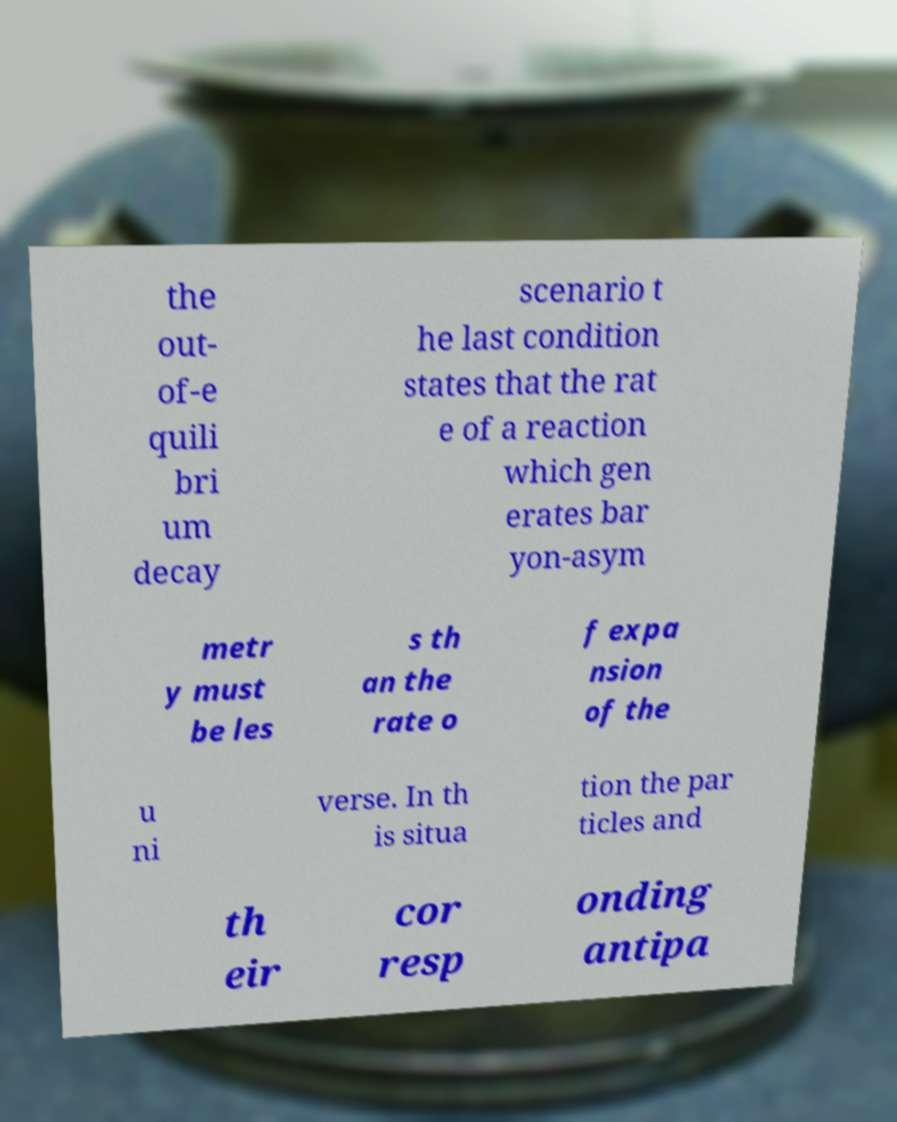What messages or text are displayed in this image? I need them in a readable, typed format. the out- of-e quili bri um decay scenario t he last condition states that the rat e of a reaction which gen erates bar yon-asym metr y must be les s th an the rate o f expa nsion of the u ni verse. In th is situa tion the par ticles and th eir cor resp onding antipa 